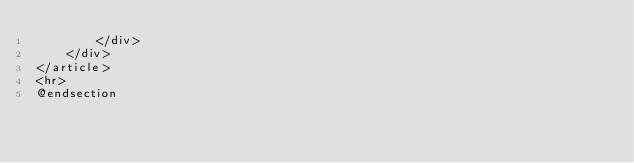<code> <loc_0><loc_0><loc_500><loc_500><_PHP_>        </div>
    </div>
</article>
<hr>
@endsection</code> 